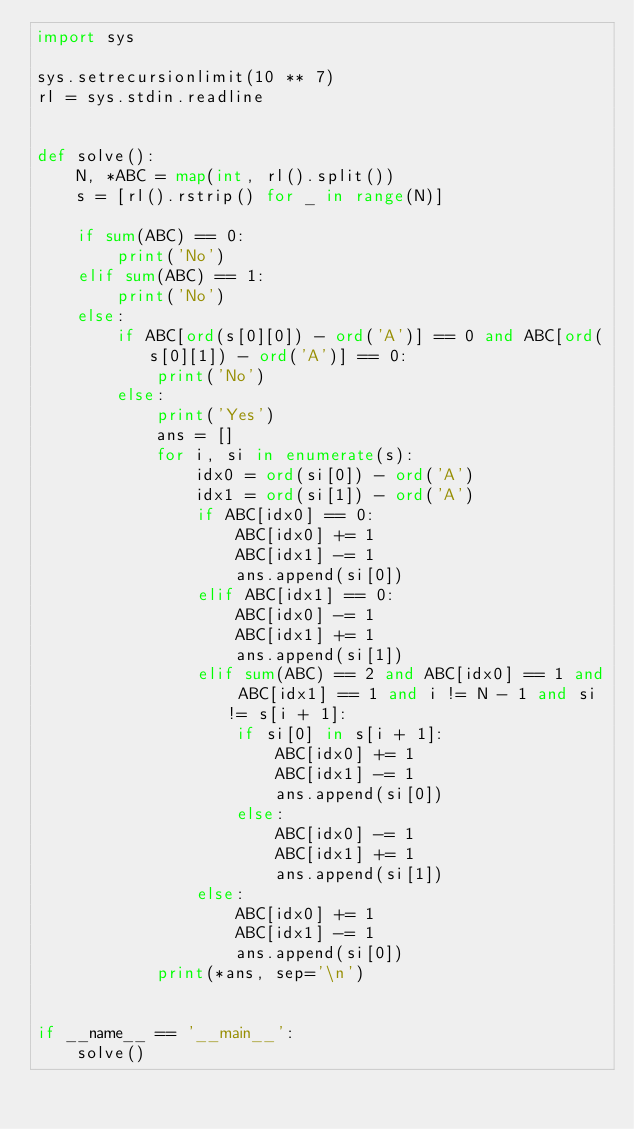<code> <loc_0><loc_0><loc_500><loc_500><_Python_>import sys

sys.setrecursionlimit(10 ** 7)
rl = sys.stdin.readline


def solve():
    N, *ABC = map(int, rl().split())
    s = [rl().rstrip() for _ in range(N)]
    
    if sum(ABC) == 0:
        print('No')
    elif sum(ABC) == 1:
        print('No')
    else:
        if ABC[ord(s[0][0]) - ord('A')] == 0 and ABC[ord(s[0][1]) - ord('A')] == 0:
            print('No')
        else:
            print('Yes')
            ans = []
            for i, si in enumerate(s):
                idx0 = ord(si[0]) - ord('A')
                idx1 = ord(si[1]) - ord('A')
                if ABC[idx0] == 0:
                    ABC[idx0] += 1
                    ABC[idx1] -= 1
                    ans.append(si[0])
                elif ABC[idx1] == 0:
                    ABC[idx0] -= 1
                    ABC[idx1] += 1
                    ans.append(si[1])
                elif sum(ABC) == 2 and ABC[idx0] == 1 and ABC[idx1] == 1 and i != N - 1 and si != s[i + 1]:
                    if si[0] in s[i + 1]:
                        ABC[idx0] += 1
                        ABC[idx1] -= 1
                        ans.append(si[0])
                    else:
                        ABC[idx0] -= 1
                        ABC[idx1] += 1
                        ans.append(si[1])
                else:
                    ABC[idx0] += 1
                    ABC[idx1] -= 1
                    ans.append(si[0])
            print(*ans, sep='\n')


if __name__ == '__main__':
    solve()
</code> 